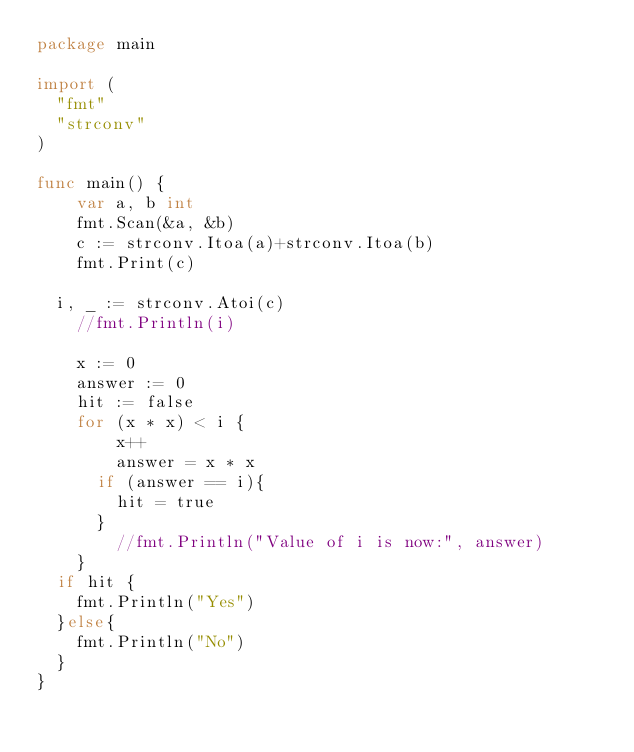Convert code to text. <code><loc_0><loc_0><loc_500><loc_500><_Go_>package main

import (
  "fmt"
  "strconv"
)

func main() {
    var a, b int
    fmt.Scan(&a, &b)
	c := strconv.Itoa(a)+strconv.Itoa(b)
    fmt.Print(c)
  
  i, _ := strconv.Atoi(c)
	//fmt.Println(i)
  
 	x := 0
 	answer := 0
	hit := false
 	for (x * x) < i { 
    	x++
      	answer = x * x
      if (answer == i){
        hit = true
      }
	    //fmt.Println("Value of i is now:", answer)
	}
  if hit {
    fmt.Println("Yes")
  }else{
    fmt.Println("No")
  }
}
</code> 